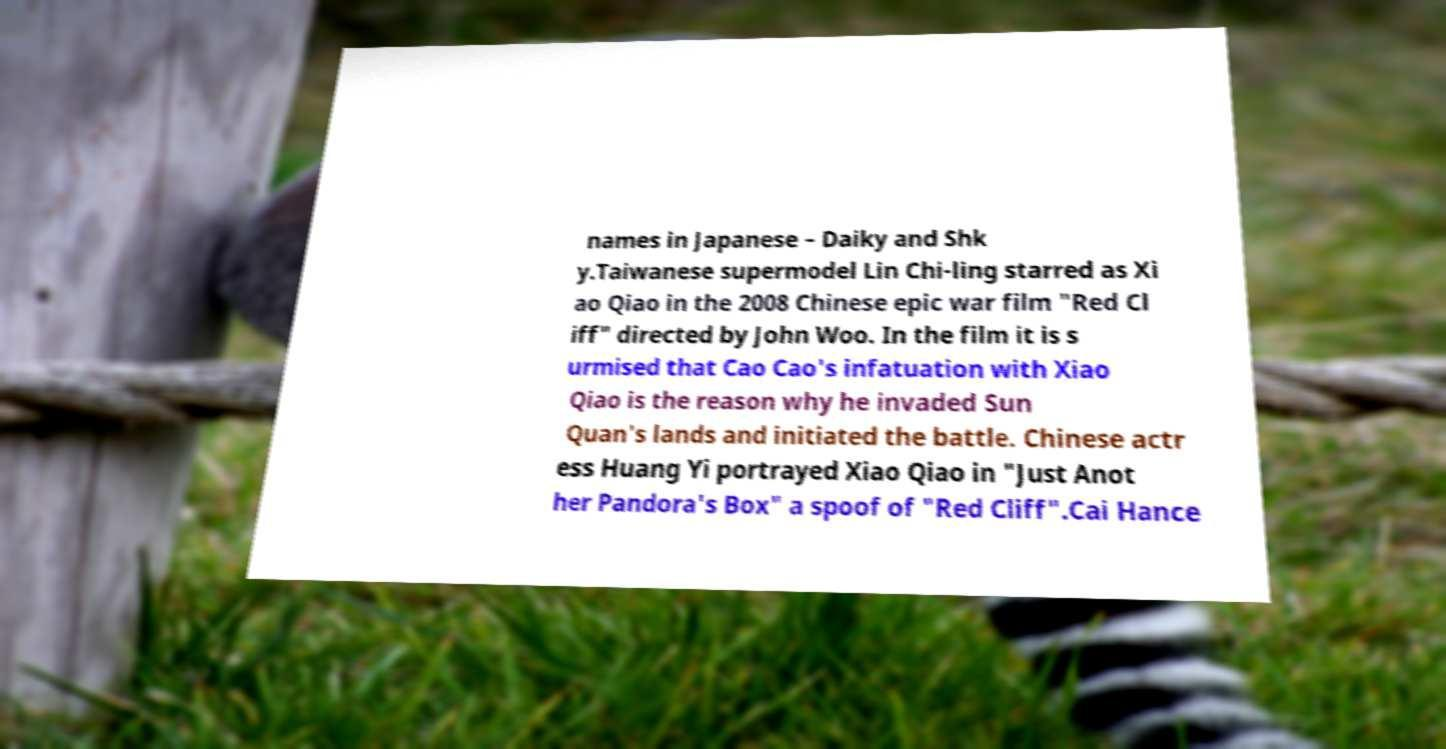Could you assist in decoding the text presented in this image and type it out clearly? names in Japanese – Daiky and Shk y.Taiwanese supermodel Lin Chi-ling starred as Xi ao Qiao in the 2008 Chinese epic war film "Red Cl iff" directed by John Woo. In the film it is s urmised that Cao Cao's infatuation with Xiao Qiao is the reason why he invaded Sun Quan's lands and initiated the battle. Chinese actr ess Huang Yi portrayed Xiao Qiao in "Just Anot her Pandora's Box" a spoof of "Red Cliff".Cai Hance 